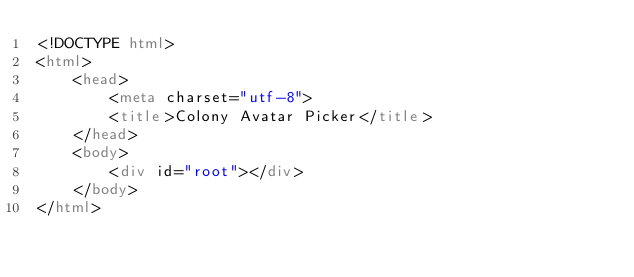<code> <loc_0><loc_0><loc_500><loc_500><_HTML_><!DOCTYPE html>
<html>
	<head>
		<meta charset="utf-8">
		<title>Colony Avatar Picker</title>
	</head>
	<body>
		<div id="root"></div>
	</body>
</html>
</code> 